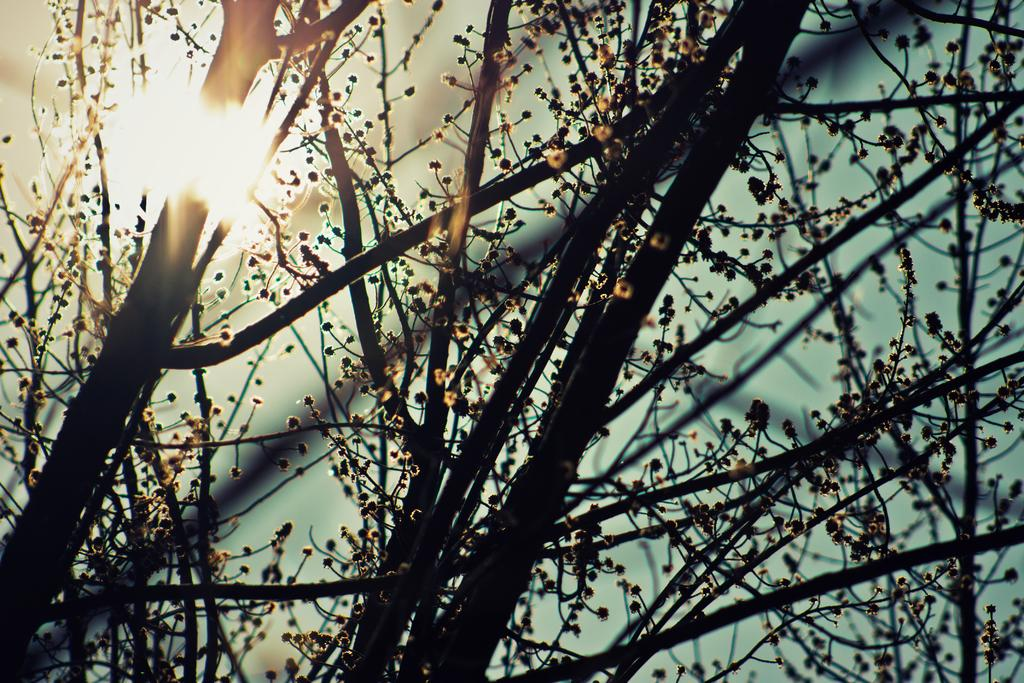What type of vegetation can be seen in the image? There are trees in the image. What is the source of light in the image? There is sunlight visible in the image. Based on the presence of sunlight, when do you think the image was taken? The image was likely taken during the day. What color of paint is covering the side of the trees in the image? There is no paint visible on the trees in the image; they appear to be their natural color. How many clouds can be seen in the image? There are no clouds present in the image, as it only features trees and sunlight. 